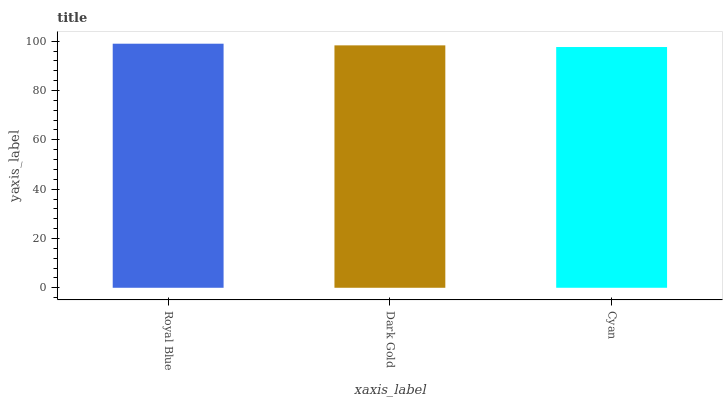Is Cyan the minimum?
Answer yes or no. Yes. Is Royal Blue the maximum?
Answer yes or no. Yes. Is Dark Gold the minimum?
Answer yes or no. No. Is Dark Gold the maximum?
Answer yes or no. No. Is Royal Blue greater than Dark Gold?
Answer yes or no. Yes. Is Dark Gold less than Royal Blue?
Answer yes or no. Yes. Is Dark Gold greater than Royal Blue?
Answer yes or no. No. Is Royal Blue less than Dark Gold?
Answer yes or no. No. Is Dark Gold the high median?
Answer yes or no. Yes. Is Dark Gold the low median?
Answer yes or no. Yes. Is Royal Blue the high median?
Answer yes or no. No. Is Cyan the low median?
Answer yes or no. No. 